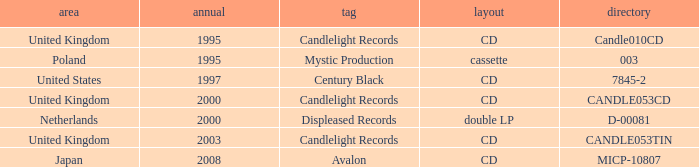What is Candlelight Records format? CD, CD, CD. 